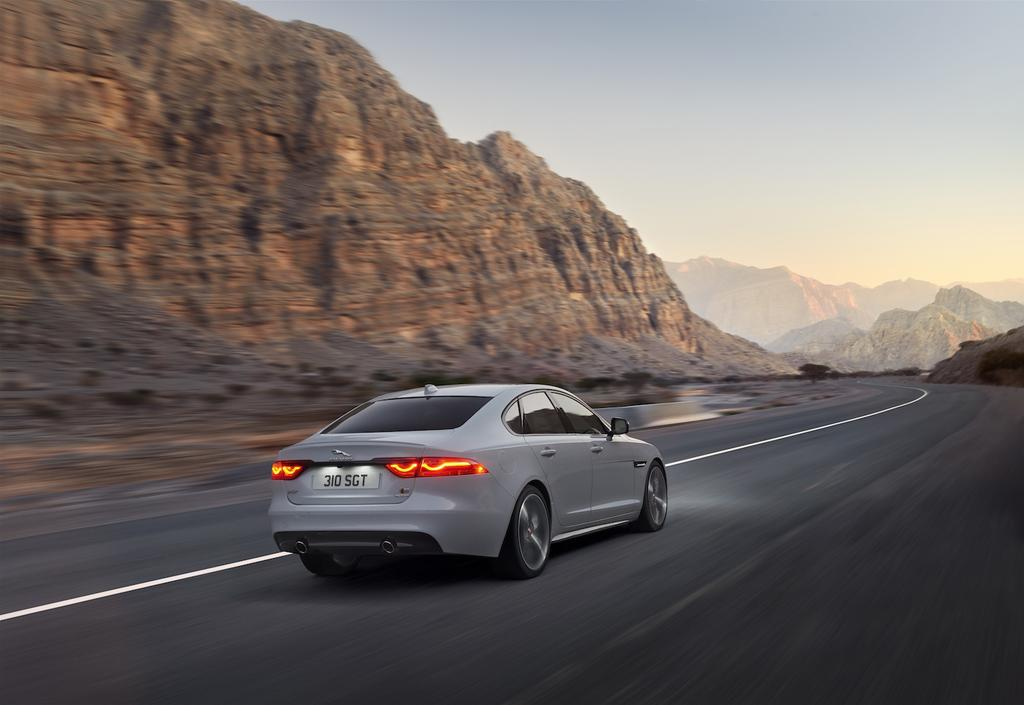What is the main subject of the image? There is a car in the image. What is the color of the car? The car is white in color. What is the car doing in the image? The car is moving on a road. What can be seen in the background of the image? There are mountains visible in the background of the image, and the sky is clear. Can you tell me how many things are being exchanged between the mountains in the image? There is no exchange of things between the mountains in the image, as they are simply a part of the background. 